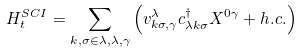<formula> <loc_0><loc_0><loc_500><loc_500>H _ { t } ^ { S C I } = \sum _ { k , \sigma \in \lambda , \lambda , \gamma } \left ( v _ { k \sigma , \gamma } ^ { \lambda } c _ { \lambda k \sigma } ^ { \dagger } X ^ { 0 \gamma } + h . c . \right )</formula> 